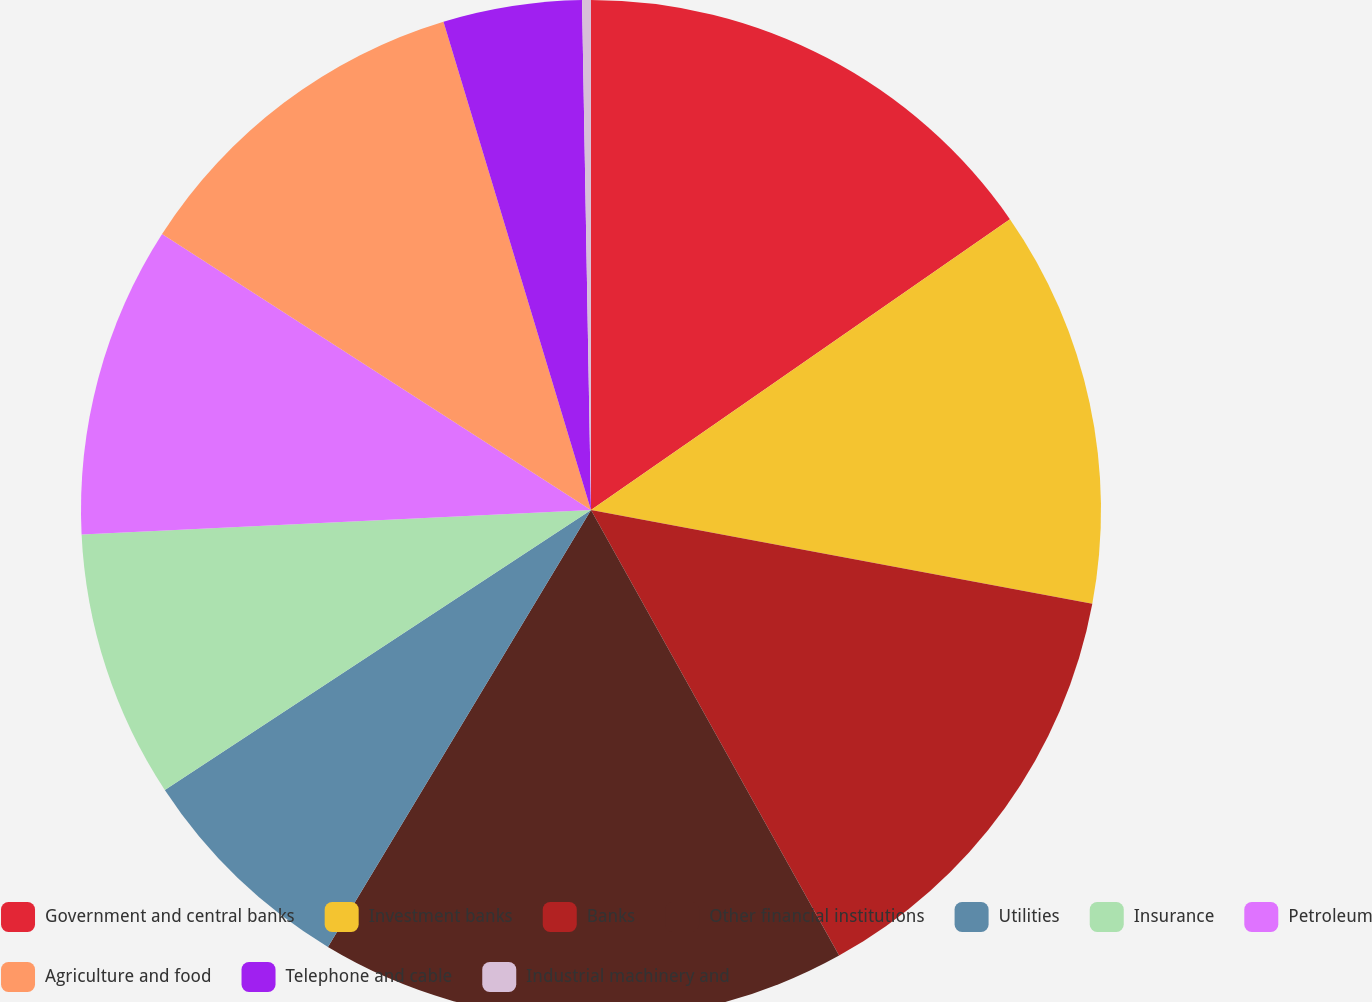<chart> <loc_0><loc_0><loc_500><loc_500><pie_chart><fcel>Government and central banks<fcel>Investment banks<fcel>Banks<fcel>Other financial institutions<fcel>Utilities<fcel>Insurance<fcel>Petroleum<fcel>Agriculture and food<fcel>Telephone and cable<fcel>Industrial machinery and<nl><fcel>15.34%<fcel>12.6%<fcel>13.97%<fcel>16.71%<fcel>7.12%<fcel>8.49%<fcel>9.86%<fcel>11.23%<fcel>4.39%<fcel>0.28%<nl></chart> 